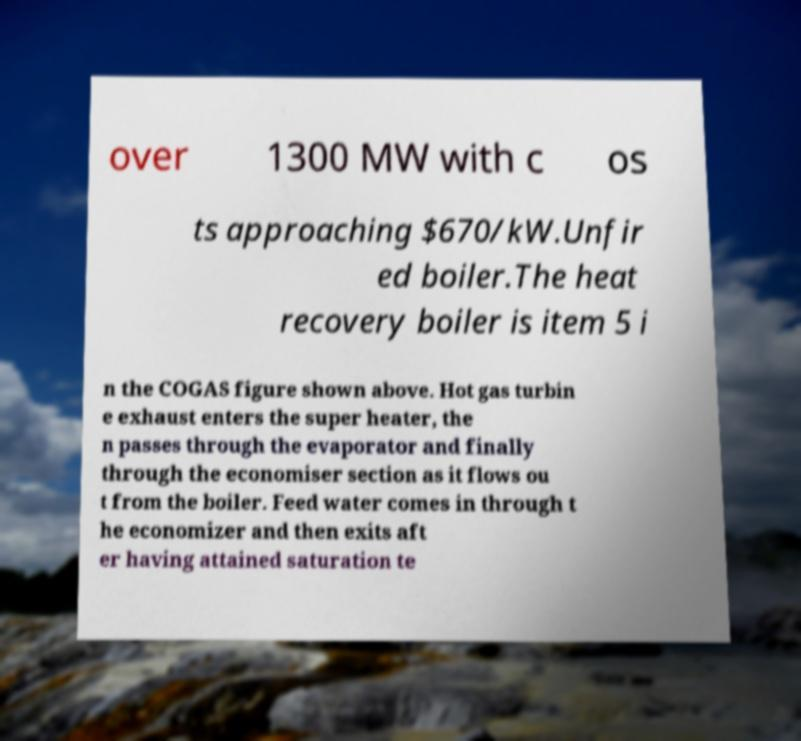Could you extract and type out the text from this image? over 1300 MW with c os ts approaching $670/kW.Unfir ed boiler.The heat recovery boiler is item 5 i n the COGAS figure shown above. Hot gas turbin e exhaust enters the super heater, the n passes through the evaporator and finally through the economiser section as it flows ou t from the boiler. Feed water comes in through t he economizer and then exits aft er having attained saturation te 